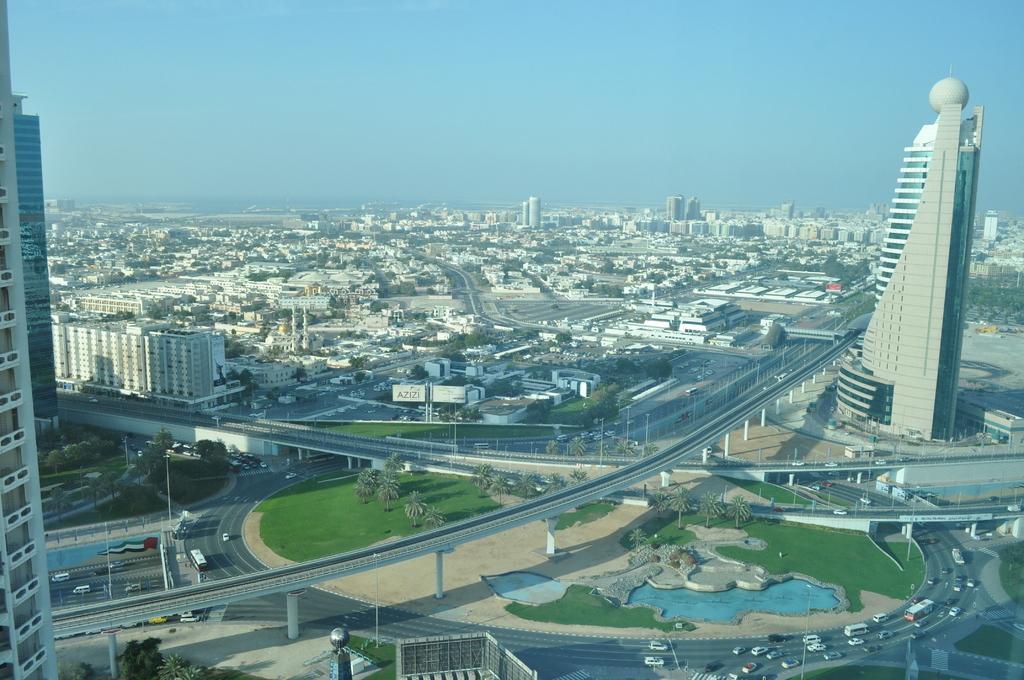Please provide a concise description of this image. This is an outside view. At the bottom of the image I can see few vehicles on the road, trees, garden, buildings and a bridge. On the top of the image I can see the sky. 